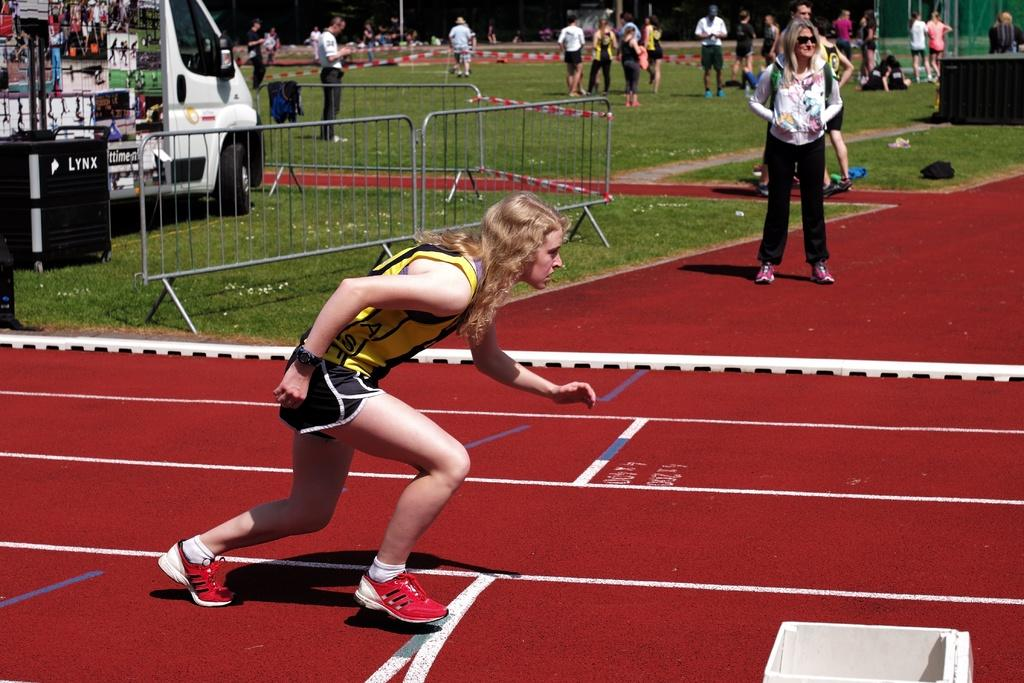<image>
Share a concise interpretation of the image provided. A runner on a track with a black container behind with the work Lynx on it. 